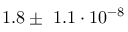Convert formula to latex. <formula><loc_0><loc_0><loc_500><loc_500>1 . 8 \pm 1 . 1 \cdot 1 0 ^ { - 8 }</formula> 